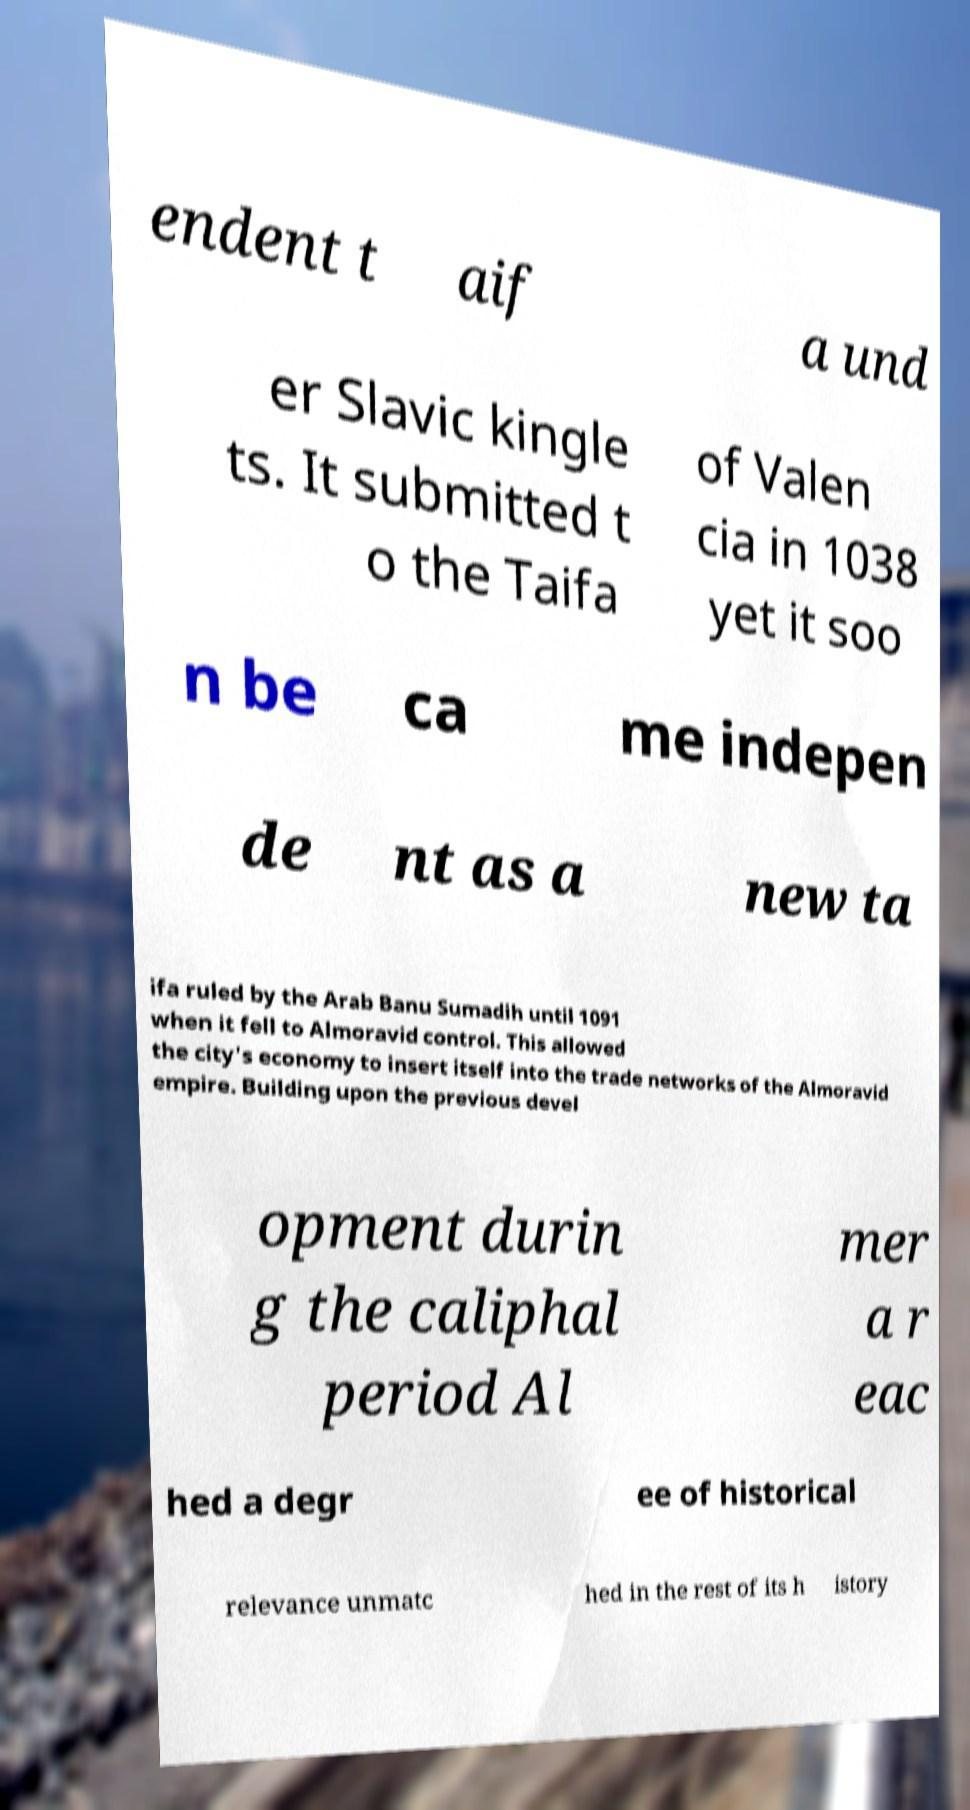Please read and relay the text visible in this image. What does it say? endent t aif a und er Slavic kingle ts. It submitted t o the Taifa of Valen cia in 1038 yet it soo n be ca me indepen de nt as a new ta ifa ruled by the Arab Banu Sumadih until 1091 when it fell to Almoravid control. This allowed the city's economy to insert itself into the trade networks of the Almoravid empire. Building upon the previous devel opment durin g the caliphal period Al mer a r eac hed a degr ee of historical relevance unmatc hed in the rest of its h istory 